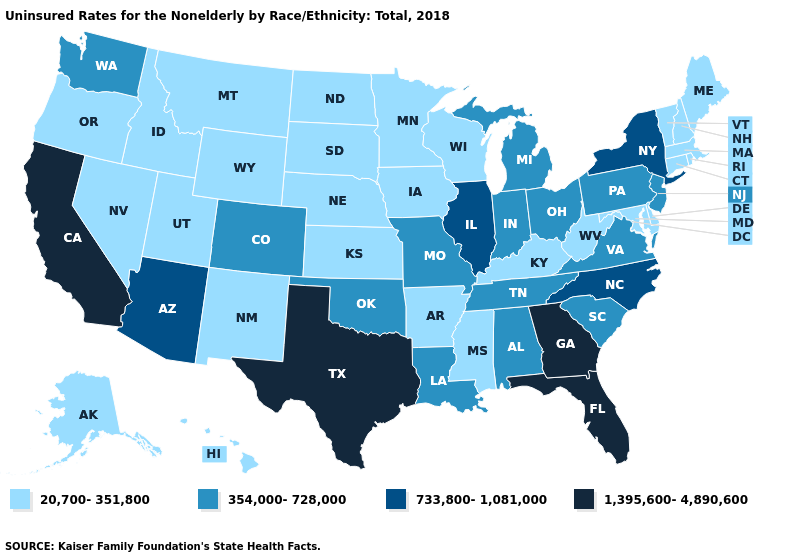What is the highest value in the South ?
Answer briefly. 1,395,600-4,890,600. Does California have the highest value in the West?
Concise answer only. Yes. What is the value of Maine?
Keep it brief. 20,700-351,800. What is the value of Mississippi?
Short answer required. 20,700-351,800. Does California have the highest value in the West?
Short answer required. Yes. What is the value of Iowa?
Keep it brief. 20,700-351,800. Which states have the lowest value in the USA?
Be succinct. Alaska, Arkansas, Connecticut, Delaware, Hawaii, Idaho, Iowa, Kansas, Kentucky, Maine, Maryland, Massachusetts, Minnesota, Mississippi, Montana, Nebraska, Nevada, New Hampshire, New Mexico, North Dakota, Oregon, Rhode Island, South Dakota, Utah, Vermont, West Virginia, Wisconsin, Wyoming. Is the legend a continuous bar?
Quick response, please. No. What is the lowest value in the USA?
Quick response, please. 20,700-351,800. Does New Mexico have the lowest value in the West?
Write a very short answer. Yes. Among the states that border Oregon , does California have the highest value?
Quick response, please. Yes. What is the value of Arizona?
Keep it brief. 733,800-1,081,000. Does Tennessee have the same value as Illinois?
Quick response, please. No. Which states have the lowest value in the South?
Be succinct. Arkansas, Delaware, Kentucky, Maryland, Mississippi, West Virginia. Does the first symbol in the legend represent the smallest category?
Give a very brief answer. Yes. 